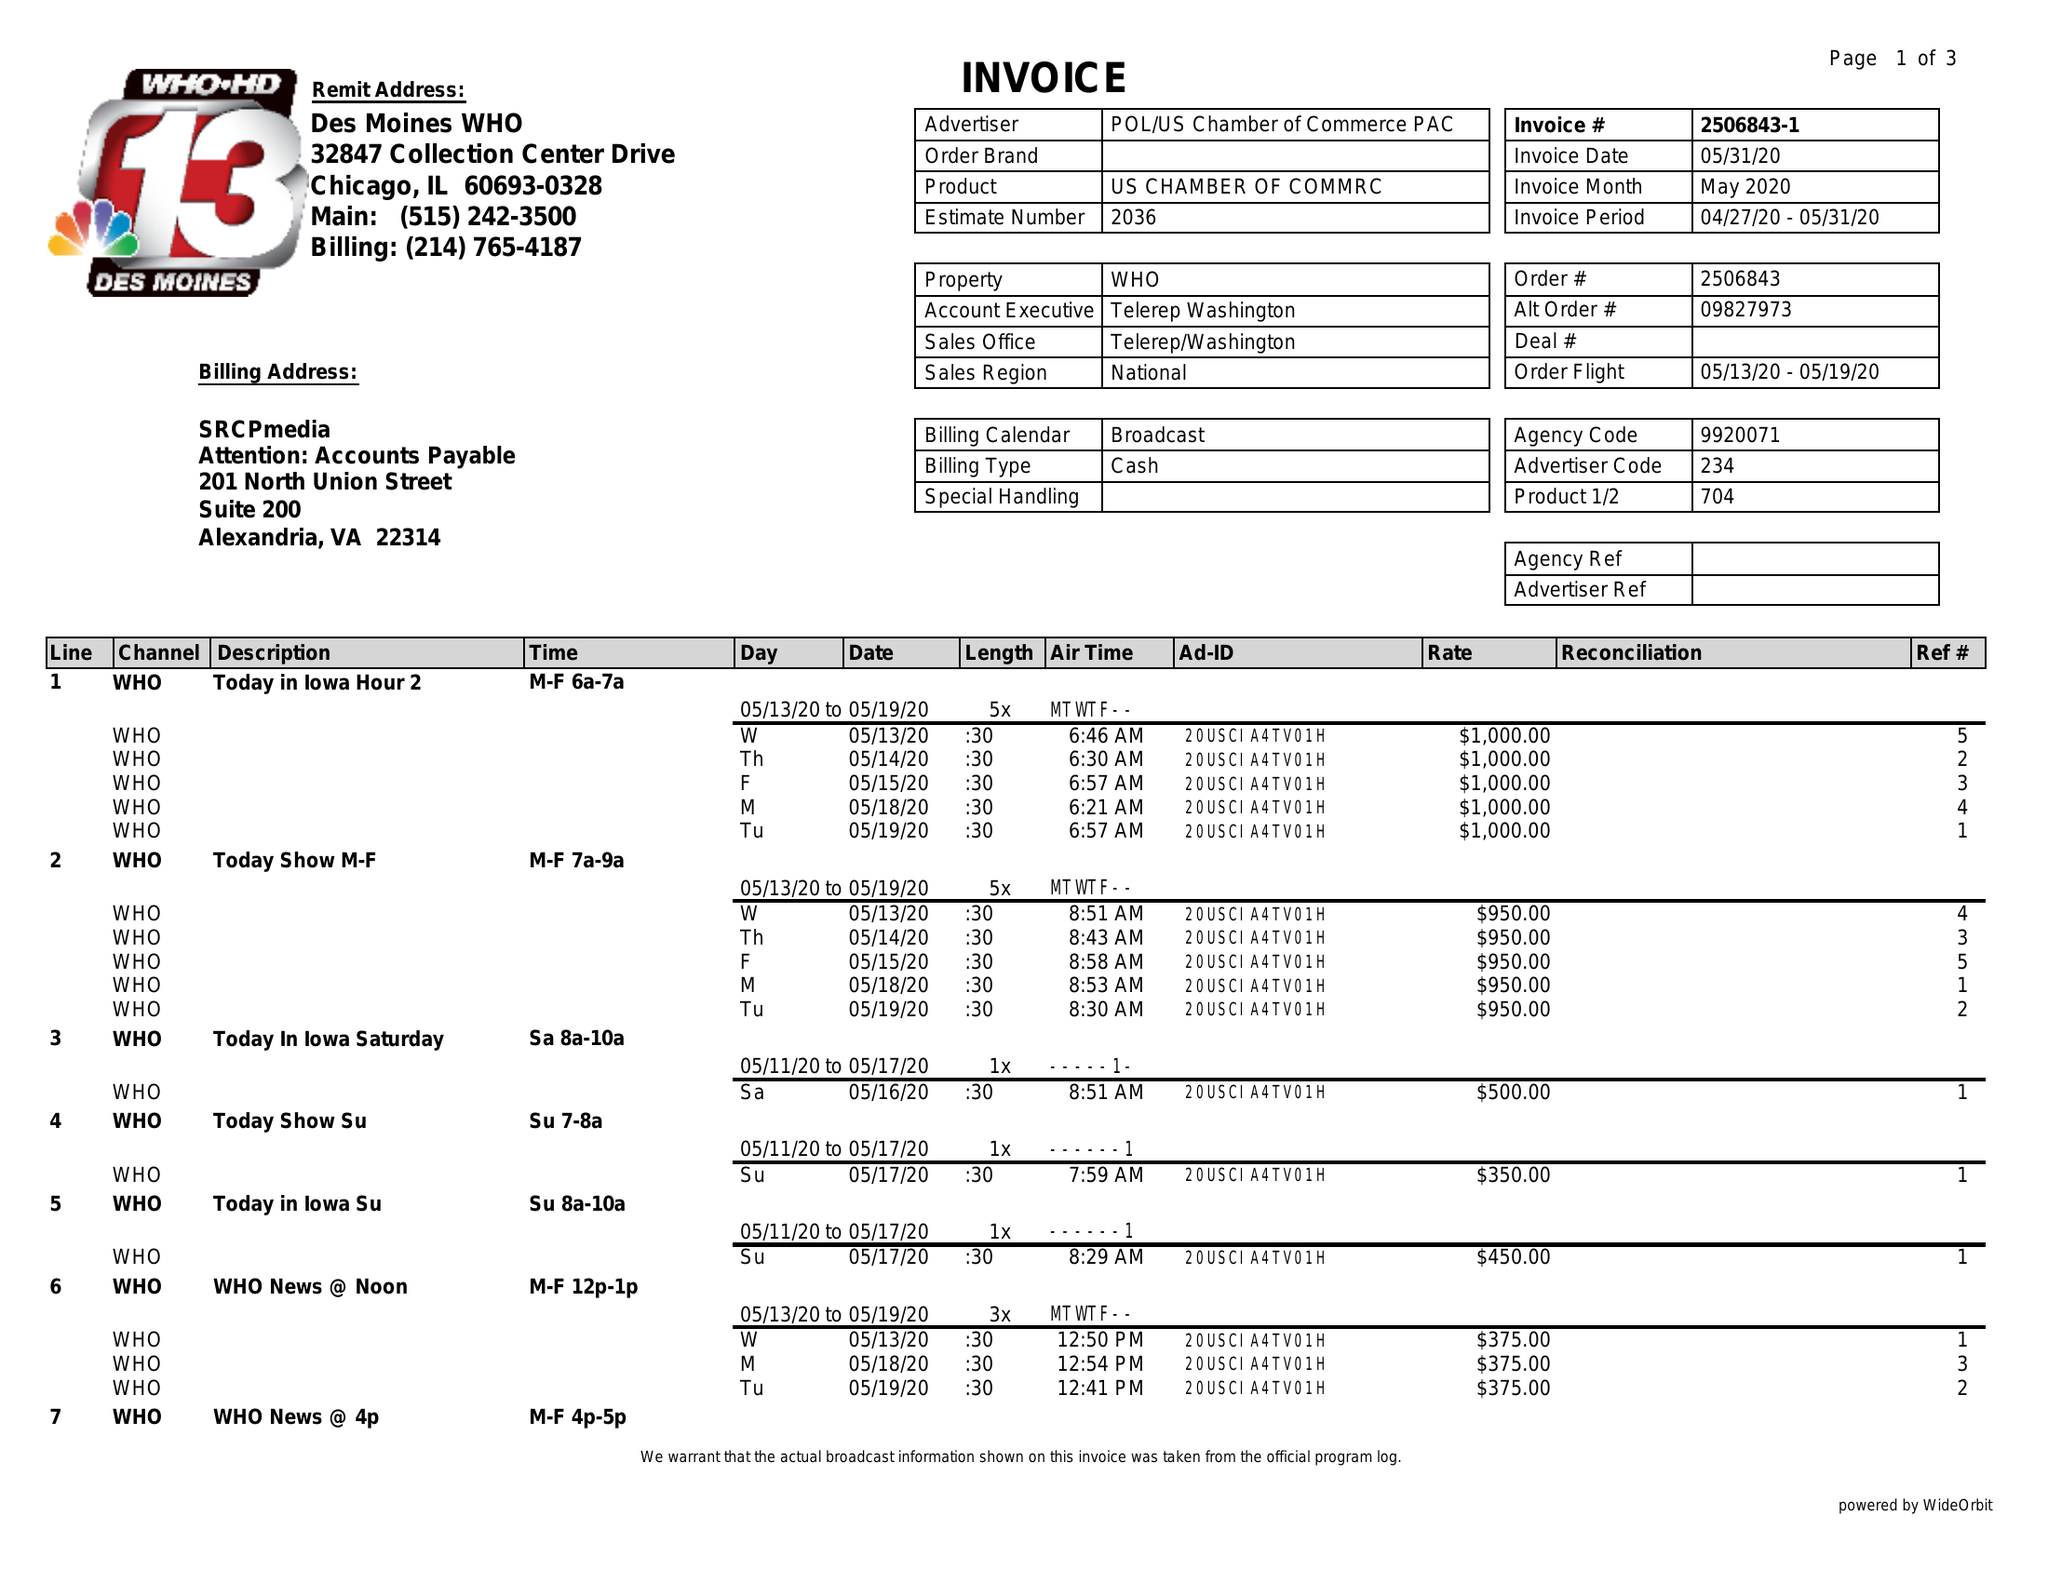What is the value for the flight_to?
Answer the question using a single word or phrase. 05/19/20 